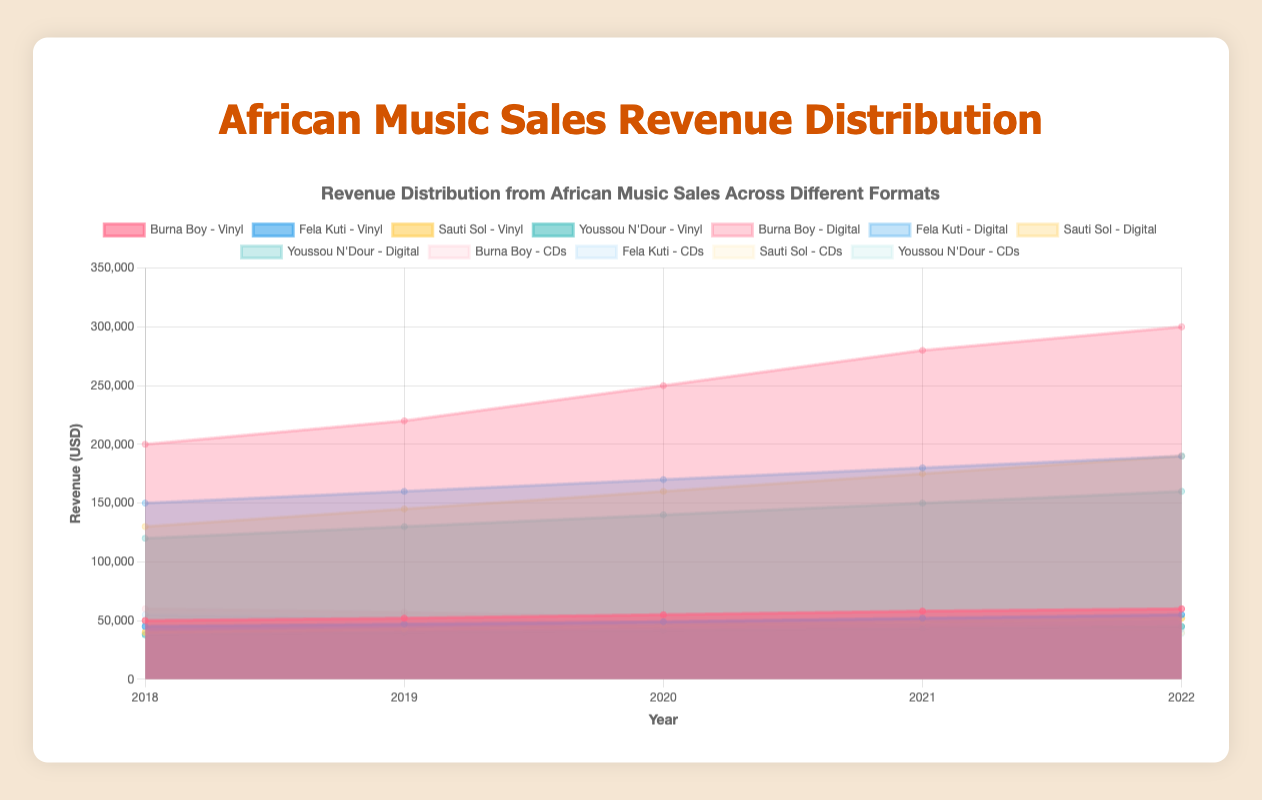What is the title of the chart? The title of the chart is displayed at the top. It reads "Revenue Distribution from African Music Sales Across Different Formats".
Answer: Revenue Distribution from African Music Sales Across Different Formats What are the three music formats represented in the chart? The chart represents three different music formats: Vinyl, Digital, and CDs. This can be inferred from the datasets and the chart legends.
Answer: Vinyl, Digital, CDs Which artist had the highest digital revenue in 2022? To determine this, compare the digital revenue values for all artists in 2022. Burna Boy has the highest digital revenue with $300,000.
Answer: Burna Boy How did Sauti Sol's vinyl revenue change from 2018 to 2022? Sauti Sol's vinyl revenue in 2018 was $40,000 and it increased steadily to $52,000 by 2022. Calculate the difference between these two values to find the change.
Answer: Increased by $12,000 What is the trend observed in Youssou N'Dour's CD revenue from 2018 to 2022? Youssou N'Dour's CD revenue declined over the years from $47,000 in 2018 to $39,000 in 2022. This consistent decrease represents a downward trend.
Answer: Decline Which format contributed the most to Burna Boy’s overall revenue in 2020? In 2020, Burna Boy's revenues across formats were: Vinyl ($55,000), Digital ($250,000), and CDs ($53,000). Digital format had the highest revenue.
Answer: Digital What is the combined total revenue for Fela Kuti across all formats in 2022? Sum Fela Kuti's revenues across all formats in 2022: Vinyl ($55,000) + Digital ($190,000) + CDs ($43,000). The total is $283,000.
Answer: $283,000 Compare the overall revenue trend of CDs for Burna Boy and Youssou N'Dour over the years. Burna Boy's CD revenue decreased from $60,000 in 2018 to $45,000 in 2022. Similarly, Youssou N'Dour's CD revenue decreased from $47,000 to $39,000 over the same period. Both artists show a downward trend in CD revenue.
Answer: Both artists' CD revenues decreased Which artist showed the most stable revenue in the digital format from 2018 to 2022? Looking at the revenue values for the digital format, Youssou N'Dour’s values show the least fluctuation, ranging from $120,000 to $160,000, indicating stability.
Answer: Youssou N'Dour In which year did Burna Boy’s total revenue from all formats peak? Calculate Burna Boy's total revenue for each year across all formats. The peak year is where the sum of revenues is highest. In 2021, it was $388,000: Vinyl ($58,000) + Digital ($280,000) + CDs ($50,000).
Answer: 2021 